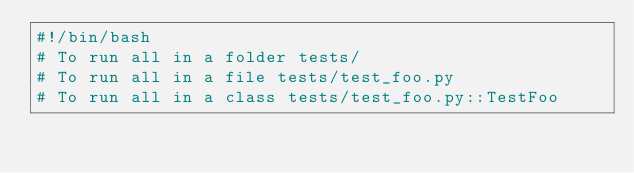Convert code to text. <code><loc_0><loc_0><loc_500><loc_500><_Bash_>#!/bin/bash
# To run all in a folder tests/
# To run all in a file tests/test_foo.py
# To run all in a class tests/test_foo.py::TestFoo</code> 